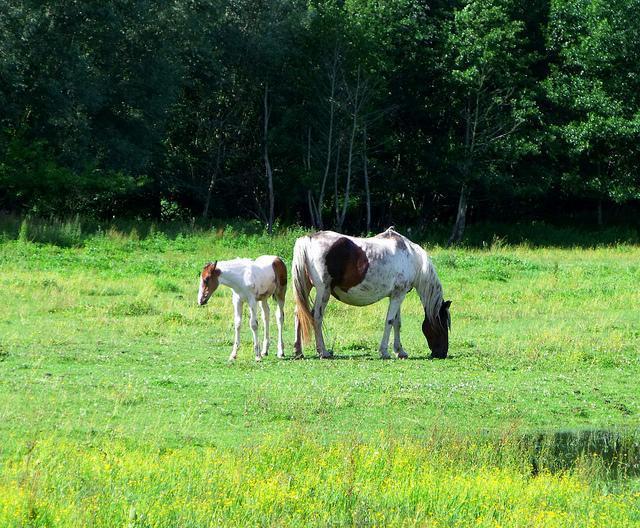How many horses are there?
Give a very brief answer. 2. 